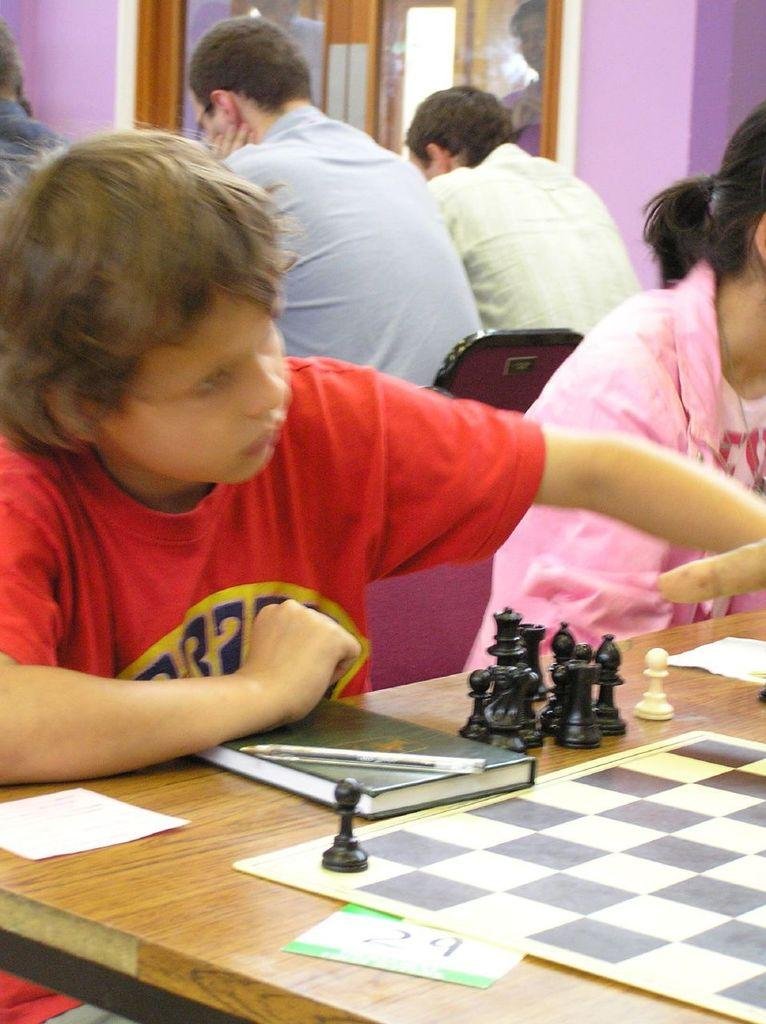How many people are in the image? There is a group of people in the image. What are the people doing in the image? The people are sitting on chairs. What is on the table in the image? There is a paper on the table. What can be seen through the window in the image? The presence of a window suggests that there might be a view or outdoor scene visible, but the specifics are not mentioned in the facts. What type of bead is being used to support the paper on the table? There is no mention of a bead in the image, and the paper is not described as being supported by any object. 